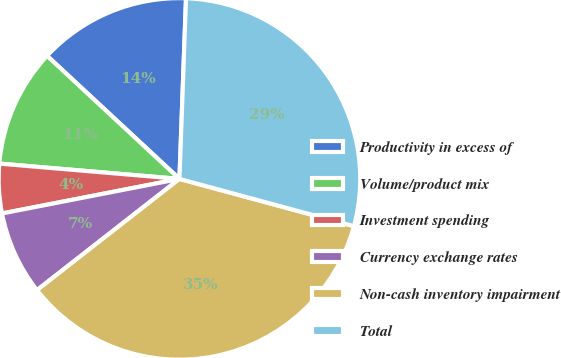<chart> <loc_0><loc_0><loc_500><loc_500><pie_chart><fcel>Productivity in excess of<fcel>Volume/product mix<fcel>Investment spending<fcel>Currency exchange rates<fcel>Non-cash inventory impairment<fcel>Total<nl><fcel>13.66%<fcel>10.57%<fcel>4.41%<fcel>7.49%<fcel>35.24%<fcel>28.63%<nl></chart> 